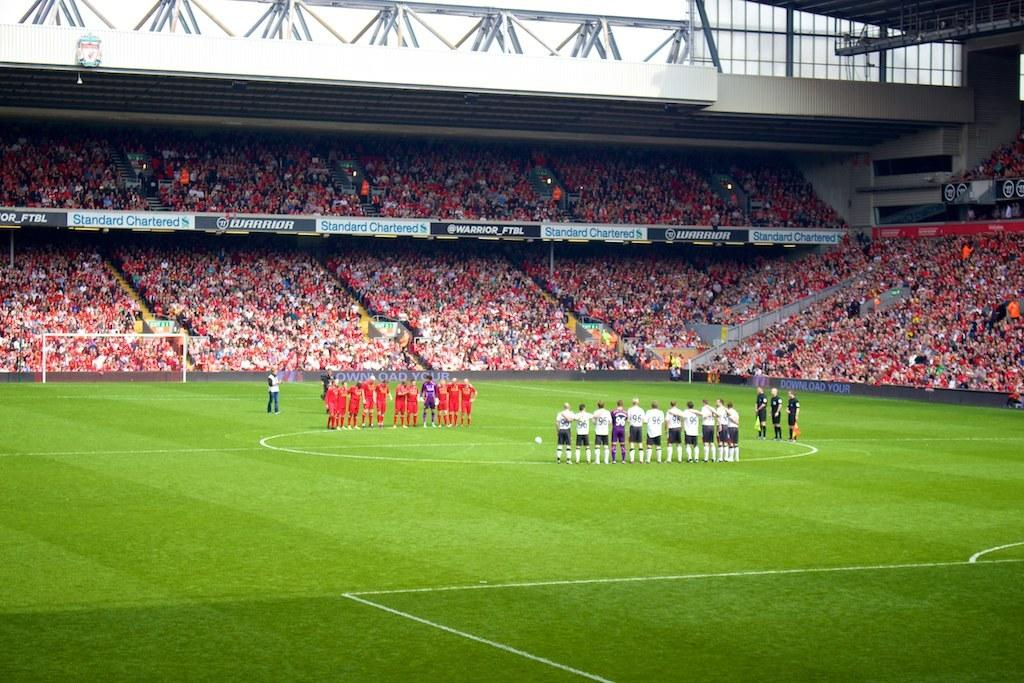Provide a one-sentence caption for the provided image. Two teams of soccer players stand on the field, an advertisement reads Warrior_FTBL. 